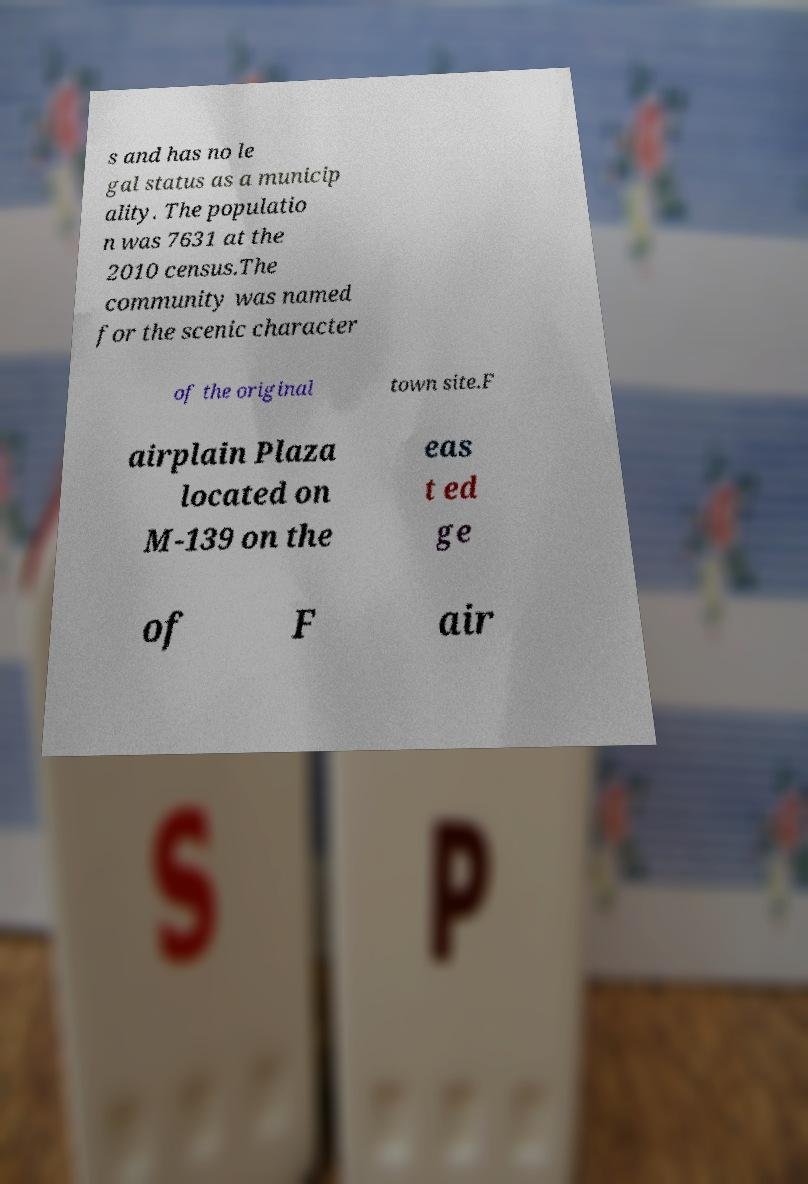For documentation purposes, I need the text within this image transcribed. Could you provide that? s and has no le gal status as a municip ality. The populatio n was 7631 at the 2010 census.The community was named for the scenic character of the original town site.F airplain Plaza located on M-139 on the eas t ed ge of F air 